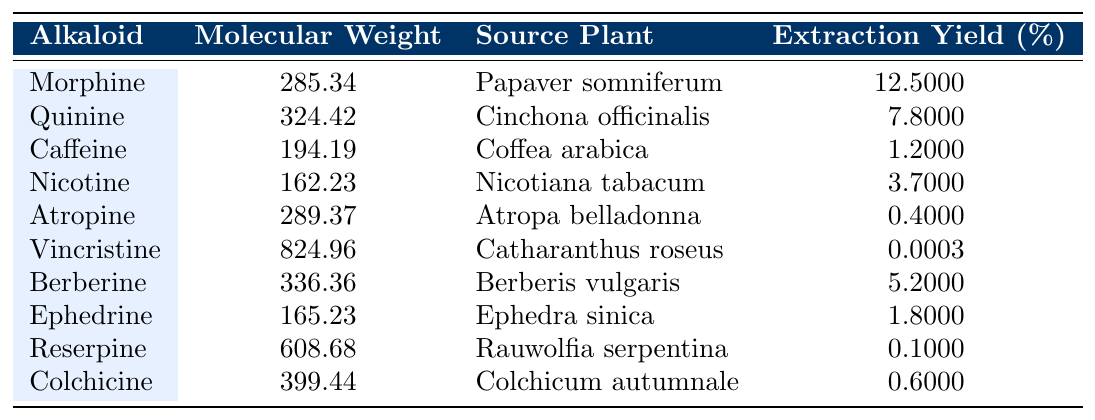What is the molecular weight of Morphine? The table lists Morphine in the alkaloids section, and its molecular weight is specified next to its name as 285.34.
Answer: 285.34 Which alkaloid has the highest molecular weight? By comparing the molecular weights in the table, Vincristine has the highest value at 824.96.
Answer: Vincristine What is the extraction yield of Caffeine? The extraction yield for Caffeine is listed directly in the table as 1.2%.
Answer: 1.2% How many alkaloids have a molecular weight greater than 300? By counting, there are 4 alkaloids (Quinine, Berberine, Colchicine, and Vincristine) with molecular weights greater than 300.
Answer: 4 Is Atropine more heavily extracted than Nicotine? Atropine's extraction yield of 0.4% is less than Nicotine's 3.7%, so the statement is false.
Answer: No What is the average molecular weight of the alkaloids listed? To find the average, sum the molecular weights (total = 285.34 + 324.42 + 194.19 + 162.23 + 289.37 + 824.96 + 336.36 + 165.23 + 608.68 + 399.44 = 3,306.88) and divide by the number of alkaloids (10). The average is 3,306.88 / 10 = 330.688.
Answer: 330.688 Which alkaloid has the lowest extraction yield, and what is that yield? The table shows that Vincristine has the lowest extraction yield at 0.0003%.
Answer: Vincristine, 0.0003% What is the difference in extraction yield between Morphine and Berberine? Morphine has an extraction yield of 12.5%, and Berberine has 5.2%. The difference is 12.5% - 5.2% = 7.3%.
Answer: 7.3% Are there any alkaloids sourced from the same plant? Both Reserpine and Atropine are sourced from plants (Rauwolfia serpentina and Atropa belladonna, respectively), so the answer is yes.
Answer: Yes What is the sum of the molecular weights of all the alkaloids? The total molecular weight is calculated by summing all entries: 285.34 + 324.42 + 194.19 + 162.23 + 289.37 + 824.96 + 336.36 + 165.23 + 608.68 + 399.44 = 3,306.88.
Answer: 3,306.88 